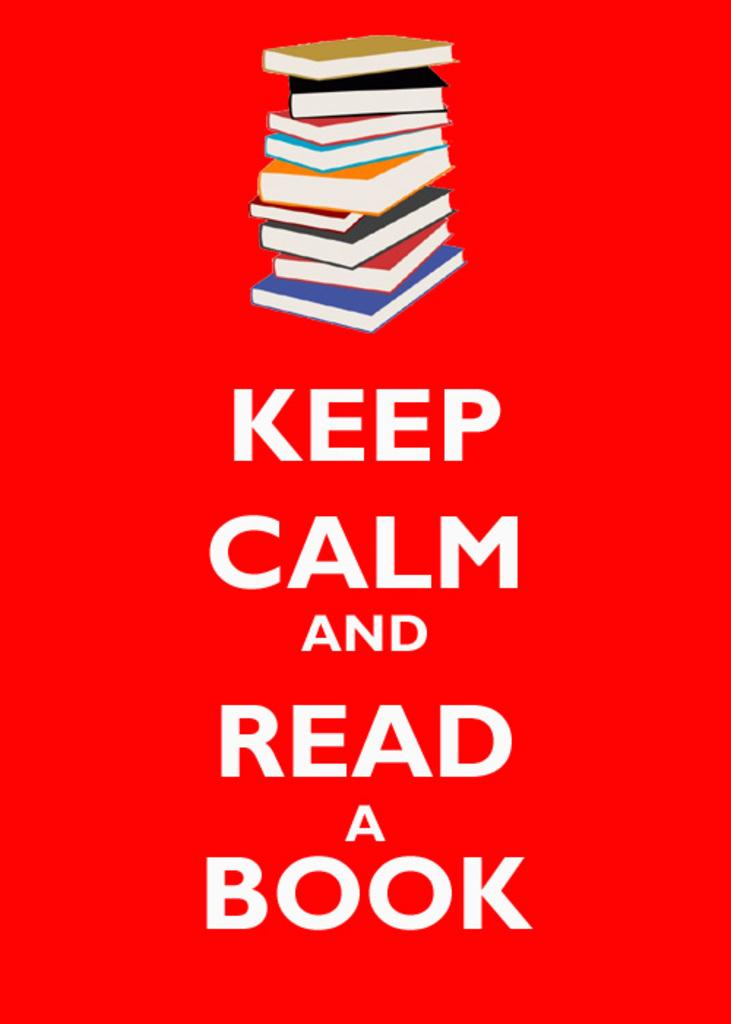Provide a one-sentence caption for the provided image. A sign with a stack of books that says Keep Calm and Read a Book. 